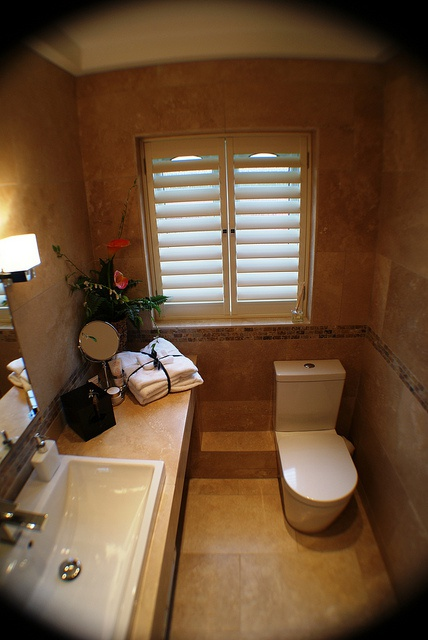Describe the objects in this image and their specific colors. I can see sink in black, tan, and darkgray tones, toilet in black, maroon, darkgray, and tan tones, potted plant in black, maroon, olive, and darkgreen tones, bottle in black, gray, and darkgray tones, and vase in black and maroon tones in this image. 